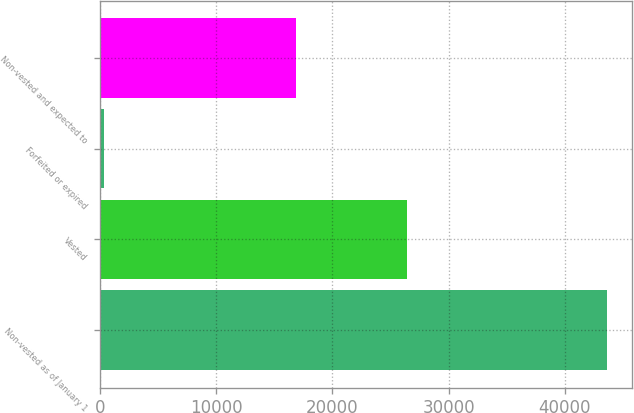Convert chart to OTSL. <chart><loc_0><loc_0><loc_500><loc_500><bar_chart><fcel>Non-vested as of January 1<fcel>Vested<fcel>Forfeited or expired<fcel>Non-vested and expected to<nl><fcel>43653<fcel>26429<fcel>352<fcel>16872<nl></chart> 